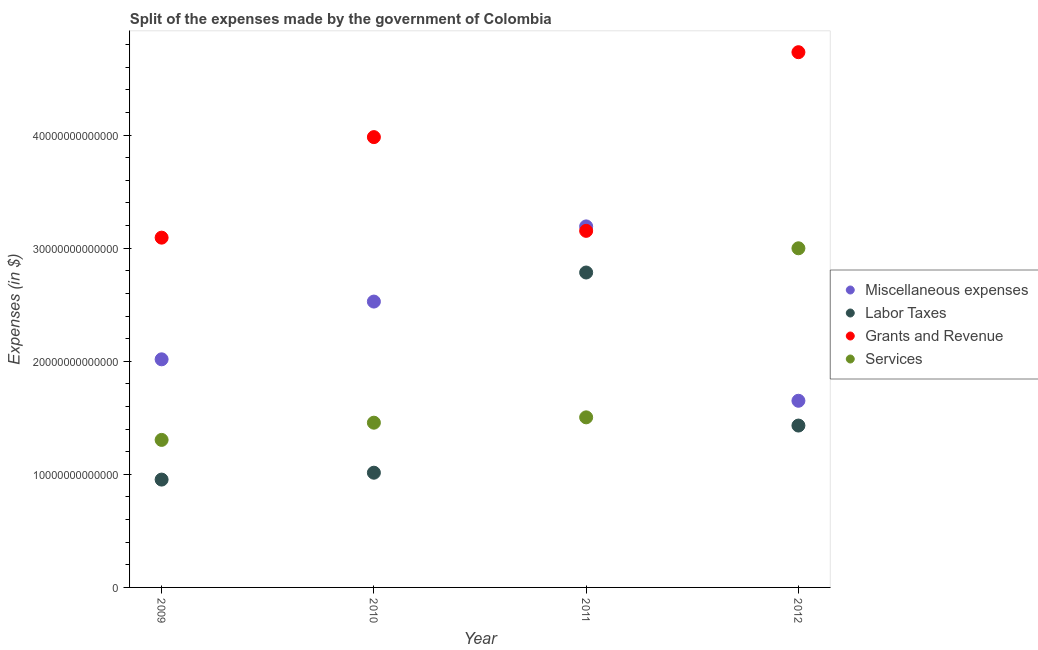How many different coloured dotlines are there?
Keep it short and to the point. 4. What is the amount spent on labor taxes in 2010?
Offer a terse response. 1.01e+13. Across all years, what is the maximum amount spent on grants and revenue?
Ensure brevity in your answer.  4.73e+13. Across all years, what is the minimum amount spent on services?
Your answer should be compact. 1.30e+13. In which year was the amount spent on grants and revenue minimum?
Offer a terse response. 2009. What is the total amount spent on miscellaneous expenses in the graph?
Offer a very short reply. 9.39e+13. What is the difference between the amount spent on services in 2010 and that in 2012?
Ensure brevity in your answer.  -1.54e+13. What is the difference between the amount spent on services in 2011 and the amount spent on labor taxes in 2012?
Offer a terse response. 7.26e+11. What is the average amount spent on miscellaneous expenses per year?
Offer a very short reply. 2.35e+13. In the year 2010, what is the difference between the amount spent on grants and revenue and amount spent on services?
Offer a very short reply. 2.53e+13. What is the ratio of the amount spent on services in 2011 to that in 2012?
Make the answer very short. 0.5. Is the amount spent on services in 2010 less than that in 2011?
Provide a short and direct response. Yes. What is the difference between the highest and the second highest amount spent on services?
Your answer should be compact. 1.49e+13. What is the difference between the highest and the lowest amount spent on services?
Your answer should be very brief. 1.69e+13. In how many years, is the amount spent on miscellaneous expenses greater than the average amount spent on miscellaneous expenses taken over all years?
Give a very brief answer. 2. Is it the case that in every year, the sum of the amount spent on miscellaneous expenses and amount spent on labor taxes is greater than the sum of amount spent on grants and revenue and amount spent on services?
Keep it short and to the point. No. Does the amount spent on grants and revenue monotonically increase over the years?
Your answer should be compact. No. How many dotlines are there?
Keep it short and to the point. 4. What is the difference between two consecutive major ticks on the Y-axis?
Give a very brief answer. 1.00e+13. Does the graph contain any zero values?
Offer a terse response. No. Where does the legend appear in the graph?
Give a very brief answer. Center right. How many legend labels are there?
Give a very brief answer. 4. How are the legend labels stacked?
Give a very brief answer. Vertical. What is the title of the graph?
Offer a very short reply. Split of the expenses made by the government of Colombia. What is the label or title of the Y-axis?
Offer a very short reply. Expenses (in $). What is the Expenses (in $) in Miscellaneous expenses in 2009?
Give a very brief answer. 2.02e+13. What is the Expenses (in $) of Labor Taxes in 2009?
Your answer should be very brief. 9.54e+12. What is the Expenses (in $) of Grants and Revenue in 2009?
Give a very brief answer. 3.09e+13. What is the Expenses (in $) in Services in 2009?
Give a very brief answer. 1.30e+13. What is the Expenses (in $) of Miscellaneous expenses in 2010?
Give a very brief answer. 2.53e+13. What is the Expenses (in $) of Labor Taxes in 2010?
Ensure brevity in your answer.  1.01e+13. What is the Expenses (in $) of Grants and Revenue in 2010?
Keep it short and to the point. 3.98e+13. What is the Expenses (in $) in Services in 2010?
Offer a very short reply. 1.46e+13. What is the Expenses (in $) of Miscellaneous expenses in 2011?
Provide a short and direct response. 3.19e+13. What is the Expenses (in $) of Labor Taxes in 2011?
Offer a terse response. 2.78e+13. What is the Expenses (in $) in Grants and Revenue in 2011?
Ensure brevity in your answer.  3.15e+13. What is the Expenses (in $) in Services in 2011?
Your answer should be compact. 1.50e+13. What is the Expenses (in $) in Miscellaneous expenses in 2012?
Provide a short and direct response. 1.65e+13. What is the Expenses (in $) in Labor Taxes in 2012?
Your answer should be compact. 1.43e+13. What is the Expenses (in $) in Grants and Revenue in 2012?
Your answer should be very brief. 4.73e+13. What is the Expenses (in $) in Services in 2012?
Ensure brevity in your answer.  3.00e+13. Across all years, what is the maximum Expenses (in $) of Miscellaneous expenses?
Your answer should be compact. 3.19e+13. Across all years, what is the maximum Expenses (in $) of Labor Taxes?
Provide a short and direct response. 2.78e+13. Across all years, what is the maximum Expenses (in $) in Grants and Revenue?
Provide a short and direct response. 4.73e+13. Across all years, what is the maximum Expenses (in $) in Services?
Ensure brevity in your answer.  3.00e+13. Across all years, what is the minimum Expenses (in $) in Miscellaneous expenses?
Give a very brief answer. 1.65e+13. Across all years, what is the minimum Expenses (in $) of Labor Taxes?
Provide a succinct answer. 9.54e+12. Across all years, what is the minimum Expenses (in $) of Grants and Revenue?
Give a very brief answer. 3.09e+13. Across all years, what is the minimum Expenses (in $) of Services?
Offer a terse response. 1.30e+13. What is the total Expenses (in $) in Miscellaneous expenses in the graph?
Offer a terse response. 9.39e+13. What is the total Expenses (in $) of Labor Taxes in the graph?
Ensure brevity in your answer.  6.18e+13. What is the total Expenses (in $) of Grants and Revenue in the graph?
Your answer should be compact. 1.50e+14. What is the total Expenses (in $) of Services in the graph?
Ensure brevity in your answer.  7.26e+13. What is the difference between the Expenses (in $) of Miscellaneous expenses in 2009 and that in 2010?
Offer a terse response. -5.11e+12. What is the difference between the Expenses (in $) in Labor Taxes in 2009 and that in 2010?
Offer a very short reply. -6.08e+11. What is the difference between the Expenses (in $) of Grants and Revenue in 2009 and that in 2010?
Ensure brevity in your answer.  -8.89e+12. What is the difference between the Expenses (in $) of Services in 2009 and that in 2010?
Offer a terse response. -1.52e+12. What is the difference between the Expenses (in $) in Miscellaneous expenses in 2009 and that in 2011?
Provide a succinct answer. -1.18e+13. What is the difference between the Expenses (in $) of Labor Taxes in 2009 and that in 2011?
Make the answer very short. -1.83e+13. What is the difference between the Expenses (in $) in Grants and Revenue in 2009 and that in 2011?
Offer a very short reply. -6.01e+11. What is the difference between the Expenses (in $) in Services in 2009 and that in 2011?
Your answer should be compact. -1.99e+12. What is the difference between the Expenses (in $) of Miscellaneous expenses in 2009 and that in 2012?
Provide a short and direct response. 3.66e+12. What is the difference between the Expenses (in $) in Labor Taxes in 2009 and that in 2012?
Your answer should be compact. -4.78e+12. What is the difference between the Expenses (in $) of Grants and Revenue in 2009 and that in 2012?
Your answer should be compact. -1.64e+13. What is the difference between the Expenses (in $) in Services in 2009 and that in 2012?
Make the answer very short. -1.69e+13. What is the difference between the Expenses (in $) in Miscellaneous expenses in 2010 and that in 2011?
Offer a very short reply. -6.65e+12. What is the difference between the Expenses (in $) of Labor Taxes in 2010 and that in 2011?
Make the answer very short. -1.77e+13. What is the difference between the Expenses (in $) in Grants and Revenue in 2010 and that in 2011?
Ensure brevity in your answer.  8.29e+12. What is the difference between the Expenses (in $) of Services in 2010 and that in 2011?
Provide a short and direct response. -4.73e+11. What is the difference between the Expenses (in $) in Miscellaneous expenses in 2010 and that in 2012?
Keep it short and to the point. 8.77e+12. What is the difference between the Expenses (in $) of Labor Taxes in 2010 and that in 2012?
Your answer should be compact. -4.17e+12. What is the difference between the Expenses (in $) of Grants and Revenue in 2010 and that in 2012?
Provide a succinct answer. -7.51e+12. What is the difference between the Expenses (in $) of Services in 2010 and that in 2012?
Your answer should be compact. -1.54e+13. What is the difference between the Expenses (in $) of Miscellaneous expenses in 2011 and that in 2012?
Offer a terse response. 1.54e+13. What is the difference between the Expenses (in $) of Labor Taxes in 2011 and that in 2012?
Give a very brief answer. 1.35e+13. What is the difference between the Expenses (in $) in Grants and Revenue in 2011 and that in 2012?
Give a very brief answer. -1.58e+13. What is the difference between the Expenses (in $) in Services in 2011 and that in 2012?
Give a very brief answer. -1.49e+13. What is the difference between the Expenses (in $) in Miscellaneous expenses in 2009 and the Expenses (in $) in Labor Taxes in 2010?
Offer a terse response. 1.00e+13. What is the difference between the Expenses (in $) of Miscellaneous expenses in 2009 and the Expenses (in $) of Grants and Revenue in 2010?
Offer a terse response. -1.96e+13. What is the difference between the Expenses (in $) of Miscellaneous expenses in 2009 and the Expenses (in $) of Services in 2010?
Offer a terse response. 5.60e+12. What is the difference between the Expenses (in $) in Labor Taxes in 2009 and the Expenses (in $) in Grants and Revenue in 2010?
Give a very brief answer. -3.03e+13. What is the difference between the Expenses (in $) in Labor Taxes in 2009 and the Expenses (in $) in Services in 2010?
Ensure brevity in your answer.  -5.03e+12. What is the difference between the Expenses (in $) of Grants and Revenue in 2009 and the Expenses (in $) of Services in 2010?
Give a very brief answer. 1.64e+13. What is the difference between the Expenses (in $) in Miscellaneous expenses in 2009 and the Expenses (in $) in Labor Taxes in 2011?
Offer a very short reply. -7.68e+12. What is the difference between the Expenses (in $) of Miscellaneous expenses in 2009 and the Expenses (in $) of Grants and Revenue in 2011?
Give a very brief answer. -1.14e+13. What is the difference between the Expenses (in $) of Miscellaneous expenses in 2009 and the Expenses (in $) of Services in 2011?
Provide a short and direct response. 5.13e+12. What is the difference between the Expenses (in $) of Labor Taxes in 2009 and the Expenses (in $) of Grants and Revenue in 2011?
Your answer should be compact. -2.20e+13. What is the difference between the Expenses (in $) in Labor Taxes in 2009 and the Expenses (in $) in Services in 2011?
Ensure brevity in your answer.  -5.50e+12. What is the difference between the Expenses (in $) of Grants and Revenue in 2009 and the Expenses (in $) of Services in 2011?
Your answer should be very brief. 1.59e+13. What is the difference between the Expenses (in $) of Miscellaneous expenses in 2009 and the Expenses (in $) of Labor Taxes in 2012?
Make the answer very short. 5.86e+12. What is the difference between the Expenses (in $) of Miscellaneous expenses in 2009 and the Expenses (in $) of Grants and Revenue in 2012?
Offer a very short reply. -2.72e+13. What is the difference between the Expenses (in $) in Miscellaneous expenses in 2009 and the Expenses (in $) in Services in 2012?
Offer a very short reply. -9.82e+12. What is the difference between the Expenses (in $) in Labor Taxes in 2009 and the Expenses (in $) in Grants and Revenue in 2012?
Keep it short and to the point. -3.78e+13. What is the difference between the Expenses (in $) of Labor Taxes in 2009 and the Expenses (in $) of Services in 2012?
Give a very brief answer. -2.05e+13. What is the difference between the Expenses (in $) in Grants and Revenue in 2009 and the Expenses (in $) in Services in 2012?
Your answer should be compact. 9.41e+11. What is the difference between the Expenses (in $) in Miscellaneous expenses in 2010 and the Expenses (in $) in Labor Taxes in 2011?
Ensure brevity in your answer.  -2.57e+12. What is the difference between the Expenses (in $) of Miscellaneous expenses in 2010 and the Expenses (in $) of Grants and Revenue in 2011?
Your response must be concise. -6.25e+12. What is the difference between the Expenses (in $) in Miscellaneous expenses in 2010 and the Expenses (in $) in Services in 2011?
Offer a terse response. 1.02e+13. What is the difference between the Expenses (in $) of Labor Taxes in 2010 and the Expenses (in $) of Grants and Revenue in 2011?
Offer a very short reply. -2.14e+13. What is the difference between the Expenses (in $) in Labor Taxes in 2010 and the Expenses (in $) in Services in 2011?
Give a very brief answer. -4.90e+12. What is the difference between the Expenses (in $) in Grants and Revenue in 2010 and the Expenses (in $) in Services in 2011?
Provide a short and direct response. 2.48e+13. What is the difference between the Expenses (in $) in Miscellaneous expenses in 2010 and the Expenses (in $) in Labor Taxes in 2012?
Offer a very short reply. 1.10e+13. What is the difference between the Expenses (in $) of Miscellaneous expenses in 2010 and the Expenses (in $) of Grants and Revenue in 2012?
Provide a succinct answer. -2.21e+13. What is the difference between the Expenses (in $) of Miscellaneous expenses in 2010 and the Expenses (in $) of Services in 2012?
Provide a short and direct response. -4.71e+12. What is the difference between the Expenses (in $) of Labor Taxes in 2010 and the Expenses (in $) of Grants and Revenue in 2012?
Your response must be concise. -3.72e+13. What is the difference between the Expenses (in $) in Labor Taxes in 2010 and the Expenses (in $) in Services in 2012?
Keep it short and to the point. -1.98e+13. What is the difference between the Expenses (in $) in Grants and Revenue in 2010 and the Expenses (in $) in Services in 2012?
Offer a terse response. 9.83e+12. What is the difference between the Expenses (in $) of Miscellaneous expenses in 2011 and the Expenses (in $) of Labor Taxes in 2012?
Give a very brief answer. 1.76e+13. What is the difference between the Expenses (in $) of Miscellaneous expenses in 2011 and the Expenses (in $) of Grants and Revenue in 2012?
Offer a very short reply. -1.54e+13. What is the difference between the Expenses (in $) of Miscellaneous expenses in 2011 and the Expenses (in $) of Services in 2012?
Ensure brevity in your answer.  1.94e+12. What is the difference between the Expenses (in $) in Labor Taxes in 2011 and the Expenses (in $) in Grants and Revenue in 2012?
Provide a short and direct response. -1.95e+13. What is the difference between the Expenses (in $) of Labor Taxes in 2011 and the Expenses (in $) of Services in 2012?
Ensure brevity in your answer.  -2.14e+12. What is the difference between the Expenses (in $) of Grants and Revenue in 2011 and the Expenses (in $) of Services in 2012?
Your answer should be compact. 1.54e+12. What is the average Expenses (in $) of Miscellaneous expenses per year?
Offer a very short reply. 2.35e+13. What is the average Expenses (in $) of Labor Taxes per year?
Make the answer very short. 1.55e+13. What is the average Expenses (in $) in Grants and Revenue per year?
Your answer should be very brief. 3.74e+13. What is the average Expenses (in $) of Services per year?
Provide a succinct answer. 1.82e+13. In the year 2009, what is the difference between the Expenses (in $) of Miscellaneous expenses and Expenses (in $) of Labor Taxes?
Ensure brevity in your answer.  1.06e+13. In the year 2009, what is the difference between the Expenses (in $) in Miscellaneous expenses and Expenses (in $) in Grants and Revenue?
Your answer should be very brief. -1.08e+13. In the year 2009, what is the difference between the Expenses (in $) in Miscellaneous expenses and Expenses (in $) in Services?
Ensure brevity in your answer.  7.13e+12. In the year 2009, what is the difference between the Expenses (in $) of Labor Taxes and Expenses (in $) of Grants and Revenue?
Make the answer very short. -2.14e+13. In the year 2009, what is the difference between the Expenses (in $) in Labor Taxes and Expenses (in $) in Services?
Offer a very short reply. -3.51e+12. In the year 2009, what is the difference between the Expenses (in $) of Grants and Revenue and Expenses (in $) of Services?
Ensure brevity in your answer.  1.79e+13. In the year 2010, what is the difference between the Expenses (in $) of Miscellaneous expenses and Expenses (in $) of Labor Taxes?
Give a very brief answer. 1.51e+13. In the year 2010, what is the difference between the Expenses (in $) of Miscellaneous expenses and Expenses (in $) of Grants and Revenue?
Give a very brief answer. -1.45e+13. In the year 2010, what is the difference between the Expenses (in $) in Miscellaneous expenses and Expenses (in $) in Services?
Your answer should be very brief. 1.07e+13. In the year 2010, what is the difference between the Expenses (in $) in Labor Taxes and Expenses (in $) in Grants and Revenue?
Your response must be concise. -2.97e+13. In the year 2010, what is the difference between the Expenses (in $) of Labor Taxes and Expenses (in $) of Services?
Provide a short and direct response. -4.42e+12. In the year 2010, what is the difference between the Expenses (in $) in Grants and Revenue and Expenses (in $) in Services?
Your response must be concise. 2.53e+13. In the year 2011, what is the difference between the Expenses (in $) of Miscellaneous expenses and Expenses (in $) of Labor Taxes?
Make the answer very short. 4.08e+12. In the year 2011, what is the difference between the Expenses (in $) of Miscellaneous expenses and Expenses (in $) of Grants and Revenue?
Keep it short and to the point. 3.94e+11. In the year 2011, what is the difference between the Expenses (in $) in Miscellaneous expenses and Expenses (in $) in Services?
Offer a very short reply. 1.69e+13. In the year 2011, what is the difference between the Expenses (in $) in Labor Taxes and Expenses (in $) in Grants and Revenue?
Offer a terse response. -3.68e+12. In the year 2011, what is the difference between the Expenses (in $) in Labor Taxes and Expenses (in $) in Services?
Your response must be concise. 1.28e+13. In the year 2011, what is the difference between the Expenses (in $) in Grants and Revenue and Expenses (in $) in Services?
Give a very brief answer. 1.65e+13. In the year 2012, what is the difference between the Expenses (in $) in Miscellaneous expenses and Expenses (in $) in Labor Taxes?
Your response must be concise. 2.19e+12. In the year 2012, what is the difference between the Expenses (in $) in Miscellaneous expenses and Expenses (in $) in Grants and Revenue?
Provide a succinct answer. -3.08e+13. In the year 2012, what is the difference between the Expenses (in $) in Miscellaneous expenses and Expenses (in $) in Services?
Give a very brief answer. -1.35e+13. In the year 2012, what is the difference between the Expenses (in $) of Labor Taxes and Expenses (in $) of Grants and Revenue?
Ensure brevity in your answer.  -3.30e+13. In the year 2012, what is the difference between the Expenses (in $) of Labor Taxes and Expenses (in $) of Services?
Keep it short and to the point. -1.57e+13. In the year 2012, what is the difference between the Expenses (in $) of Grants and Revenue and Expenses (in $) of Services?
Provide a short and direct response. 1.73e+13. What is the ratio of the Expenses (in $) in Miscellaneous expenses in 2009 to that in 2010?
Provide a succinct answer. 0.8. What is the ratio of the Expenses (in $) of Grants and Revenue in 2009 to that in 2010?
Your answer should be compact. 0.78. What is the ratio of the Expenses (in $) of Services in 2009 to that in 2010?
Offer a very short reply. 0.9. What is the ratio of the Expenses (in $) in Miscellaneous expenses in 2009 to that in 2011?
Ensure brevity in your answer.  0.63. What is the ratio of the Expenses (in $) in Labor Taxes in 2009 to that in 2011?
Keep it short and to the point. 0.34. What is the ratio of the Expenses (in $) of Grants and Revenue in 2009 to that in 2011?
Your response must be concise. 0.98. What is the ratio of the Expenses (in $) of Services in 2009 to that in 2011?
Offer a terse response. 0.87. What is the ratio of the Expenses (in $) in Miscellaneous expenses in 2009 to that in 2012?
Your response must be concise. 1.22. What is the ratio of the Expenses (in $) in Labor Taxes in 2009 to that in 2012?
Your response must be concise. 0.67. What is the ratio of the Expenses (in $) in Grants and Revenue in 2009 to that in 2012?
Make the answer very short. 0.65. What is the ratio of the Expenses (in $) in Services in 2009 to that in 2012?
Your answer should be very brief. 0.43. What is the ratio of the Expenses (in $) of Miscellaneous expenses in 2010 to that in 2011?
Your answer should be very brief. 0.79. What is the ratio of the Expenses (in $) of Labor Taxes in 2010 to that in 2011?
Provide a short and direct response. 0.36. What is the ratio of the Expenses (in $) of Grants and Revenue in 2010 to that in 2011?
Provide a short and direct response. 1.26. What is the ratio of the Expenses (in $) in Services in 2010 to that in 2011?
Make the answer very short. 0.97. What is the ratio of the Expenses (in $) in Miscellaneous expenses in 2010 to that in 2012?
Provide a succinct answer. 1.53. What is the ratio of the Expenses (in $) of Labor Taxes in 2010 to that in 2012?
Ensure brevity in your answer.  0.71. What is the ratio of the Expenses (in $) of Grants and Revenue in 2010 to that in 2012?
Your answer should be very brief. 0.84. What is the ratio of the Expenses (in $) in Services in 2010 to that in 2012?
Make the answer very short. 0.49. What is the ratio of the Expenses (in $) in Miscellaneous expenses in 2011 to that in 2012?
Make the answer very short. 1.93. What is the ratio of the Expenses (in $) in Labor Taxes in 2011 to that in 2012?
Give a very brief answer. 1.95. What is the ratio of the Expenses (in $) in Grants and Revenue in 2011 to that in 2012?
Your answer should be very brief. 0.67. What is the ratio of the Expenses (in $) in Services in 2011 to that in 2012?
Provide a short and direct response. 0.5. What is the difference between the highest and the second highest Expenses (in $) of Miscellaneous expenses?
Ensure brevity in your answer.  6.65e+12. What is the difference between the highest and the second highest Expenses (in $) of Labor Taxes?
Give a very brief answer. 1.35e+13. What is the difference between the highest and the second highest Expenses (in $) of Grants and Revenue?
Provide a short and direct response. 7.51e+12. What is the difference between the highest and the second highest Expenses (in $) of Services?
Ensure brevity in your answer.  1.49e+13. What is the difference between the highest and the lowest Expenses (in $) in Miscellaneous expenses?
Make the answer very short. 1.54e+13. What is the difference between the highest and the lowest Expenses (in $) in Labor Taxes?
Your answer should be very brief. 1.83e+13. What is the difference between the highest and the lowest Expenses (in $) of Grants and Revenue?
Give a very brief answer. 1.64e+13. What is the difference between the highest and the lowest Expenses (in $) of Services?
Make the answer very short. 1.69e+13. 